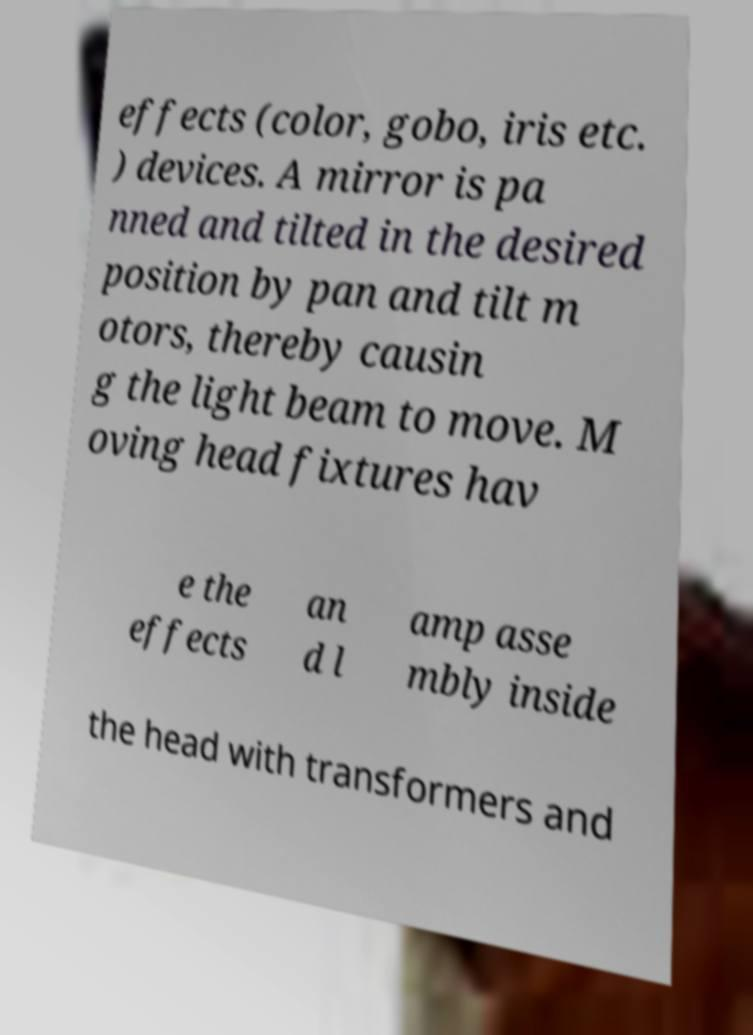Can you accurately transcribe the text from the provided image for me? effects (color, gobo, iris etc. ) devices. A mirror is pa nned and tilted in the desired position by pan and tilt m otors, thereby causin g the light beam to move. M oving head fixtures hav e the effects an d l amp asse mbly inside the head with transformers and 